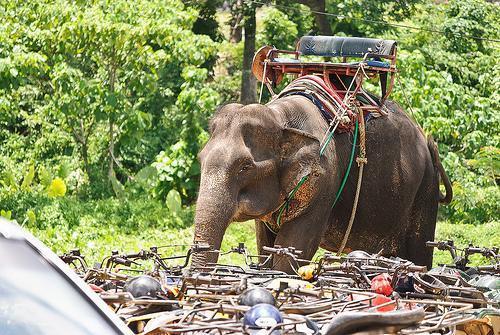How many elephants?
Give a very brief answer. 1. 